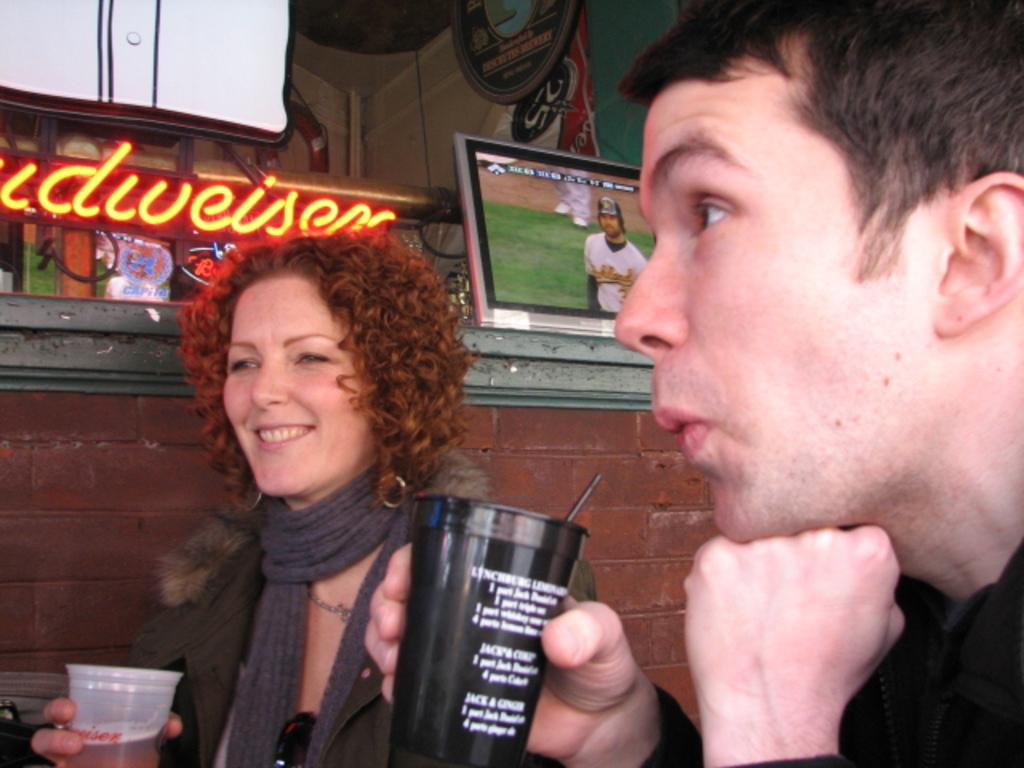How many people are present in the image? There are two people in the image. What are the people holding in their hands? Both people are holding a glass. What can be seen in the background of the image? There is a brick wall, a display, and hoardings in the background. What type of nut is being cracked by the person on the left in the image? There is no nut or person cracking a nut present in the image. Can you see a plane flying in the sky in the image? There is no plane visible in the image. 